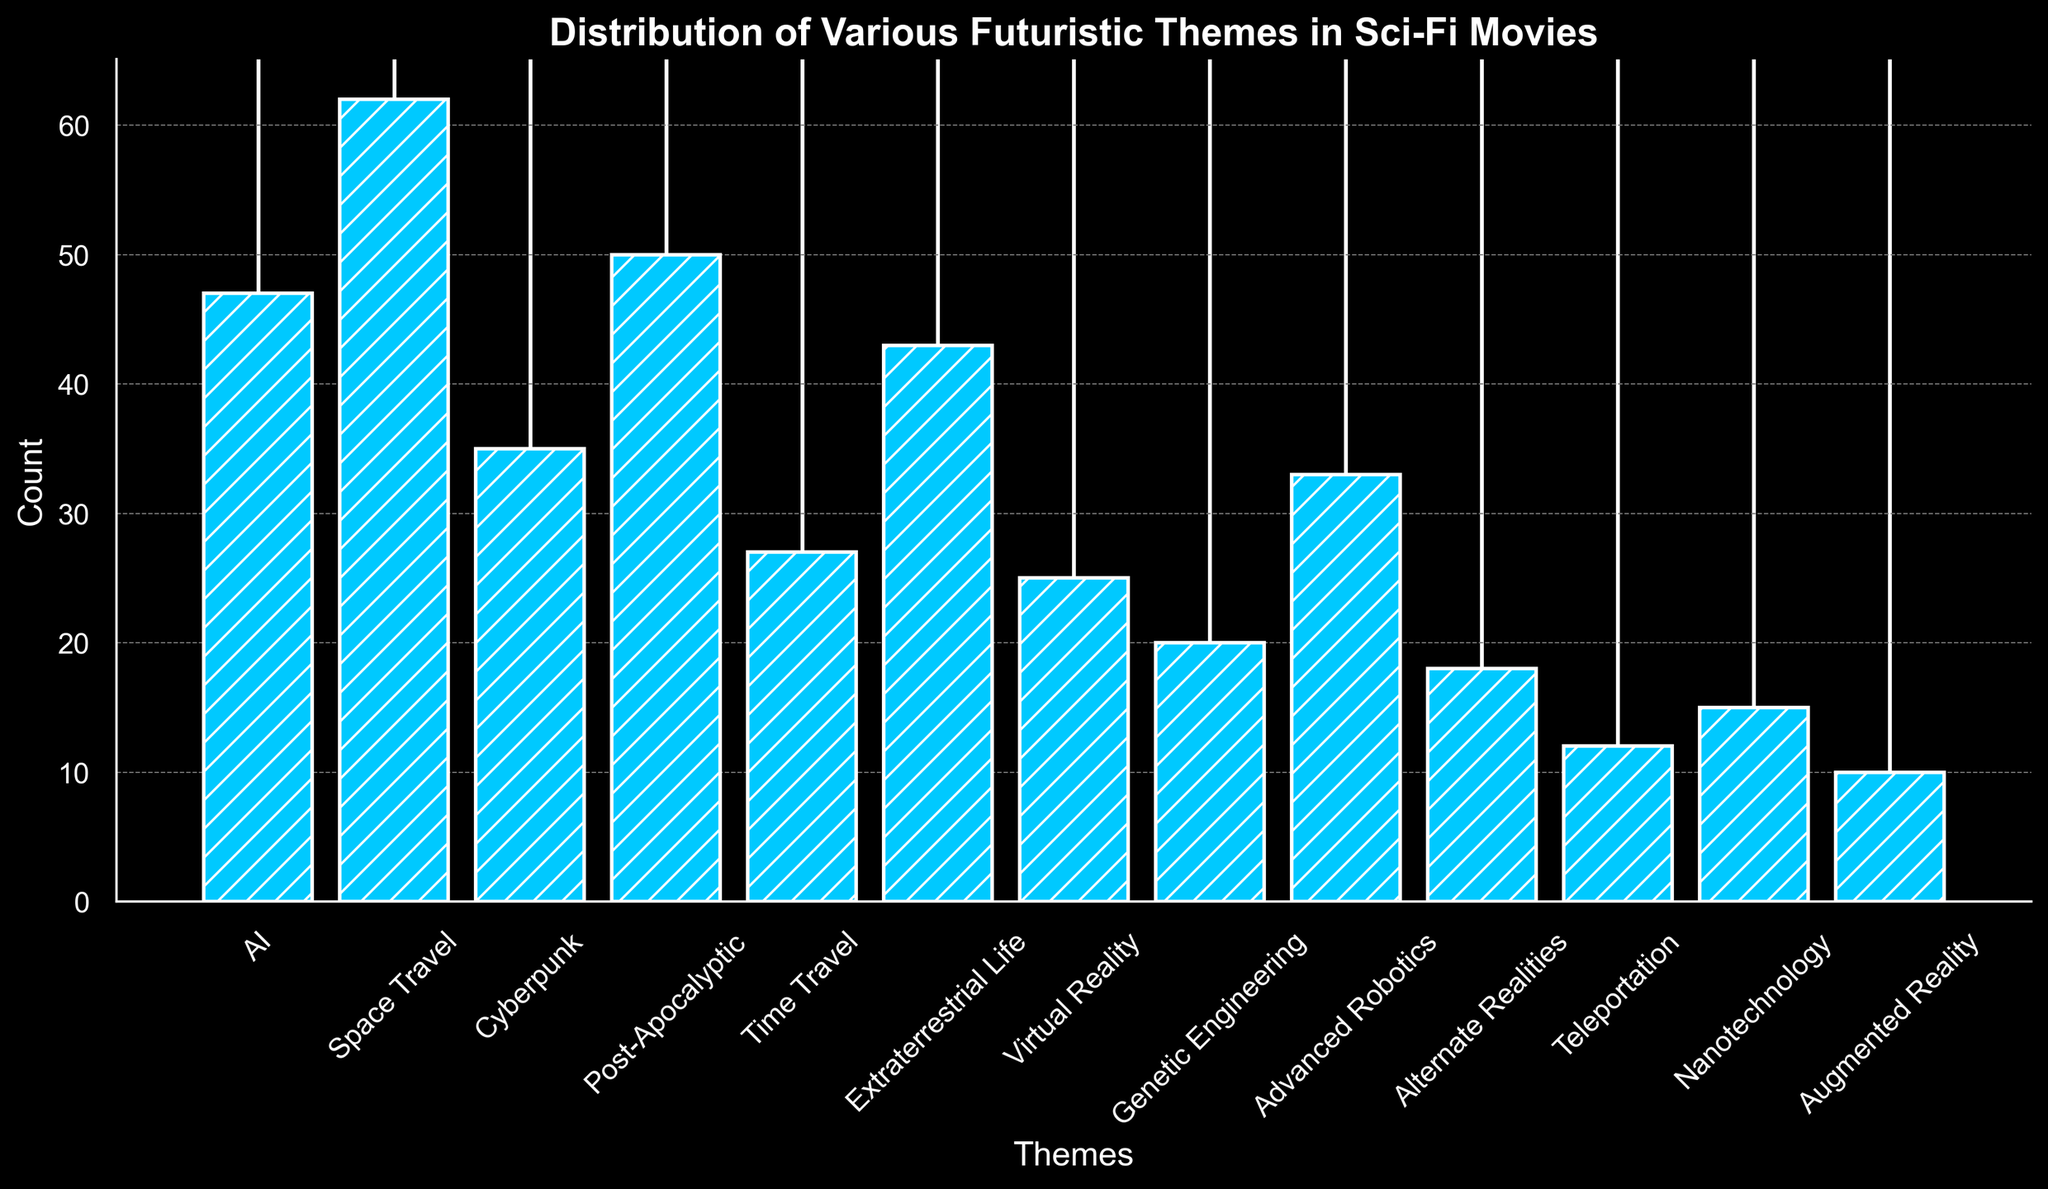Which theme is depicted the most frequently in sci-fi movies? To identify the most frequently depicted theme, look for the bar with the greatest height. "Space Travel" has the highest count.
Answer: Space Travel Which two themes together have the highest combined count? Find the two bars with the highest counts: "Space Travel" (62) and "Post-Apocalyptic" (50). Add these counts together: 62 + 50 = 112.
Answer: Space Travel and Post-Apocalyptic How many more sci-fi movies depict AI than depict Virtual Reality? Subtract the count for "Virtual Reality" (25) from the count for "AI" (47): 47 - 25 = 22.
Answer: 22 What is the total count for themes related to biological and genetic advancements (Genetic Engineering and Advanced Robotics)? Add the counts for "Genetic Engineering" (20) and "Advanced Robotics" (33): 20 + 33 = 53.
Answer: 53 Which theme has a count closest to the median count of all themes? To find the median, arrange the counts in ascending order: 10, 12, 15, 18, 20, 25, 27, 33, 35, 43, 47, 50, 62. The median is the middle value: 27. "Time Travel" has the count closest to 27.
Answer: Time Travel Are there more sci-fi movies with themes of Cyberpunk or Extraterrestrial Life? Compare the heights of the bars for "Cyberpunk" (35) and "Extraterrestrial Life" (43).
Answer: Extraterrestrial Life Which three themes have the lowest counts, and what are their total counts? Identify the three bars with the lowest counts: "Augmented Reality" (10), "Teleportation" (12), and "Nanotechnology" (15). Add their counts: 10 + 12 + 15 = 37.
Answer: Augmented Reality, Teleportation, and Nanotechnology; 37 How does the count for Post-Apocalyptic compare to the counts for AI and Cyberpunk combined? Post-Apocalyptic is 50. Add AI (47) and Cyberpunk (35): 47 + 35 = 82. 50 is less than 82.
Answer: Less What is the average count of the top four most frequent themes depicted? Identify the top four counts: "Space Travel" (62), "Post-Apocalyptic" (50), "AI" (47), "Extraterrestrial Life" (43). Calculate the average: (62 + 50 + 47 + 43) / 4 = 50.5.
Answer: 50.5 